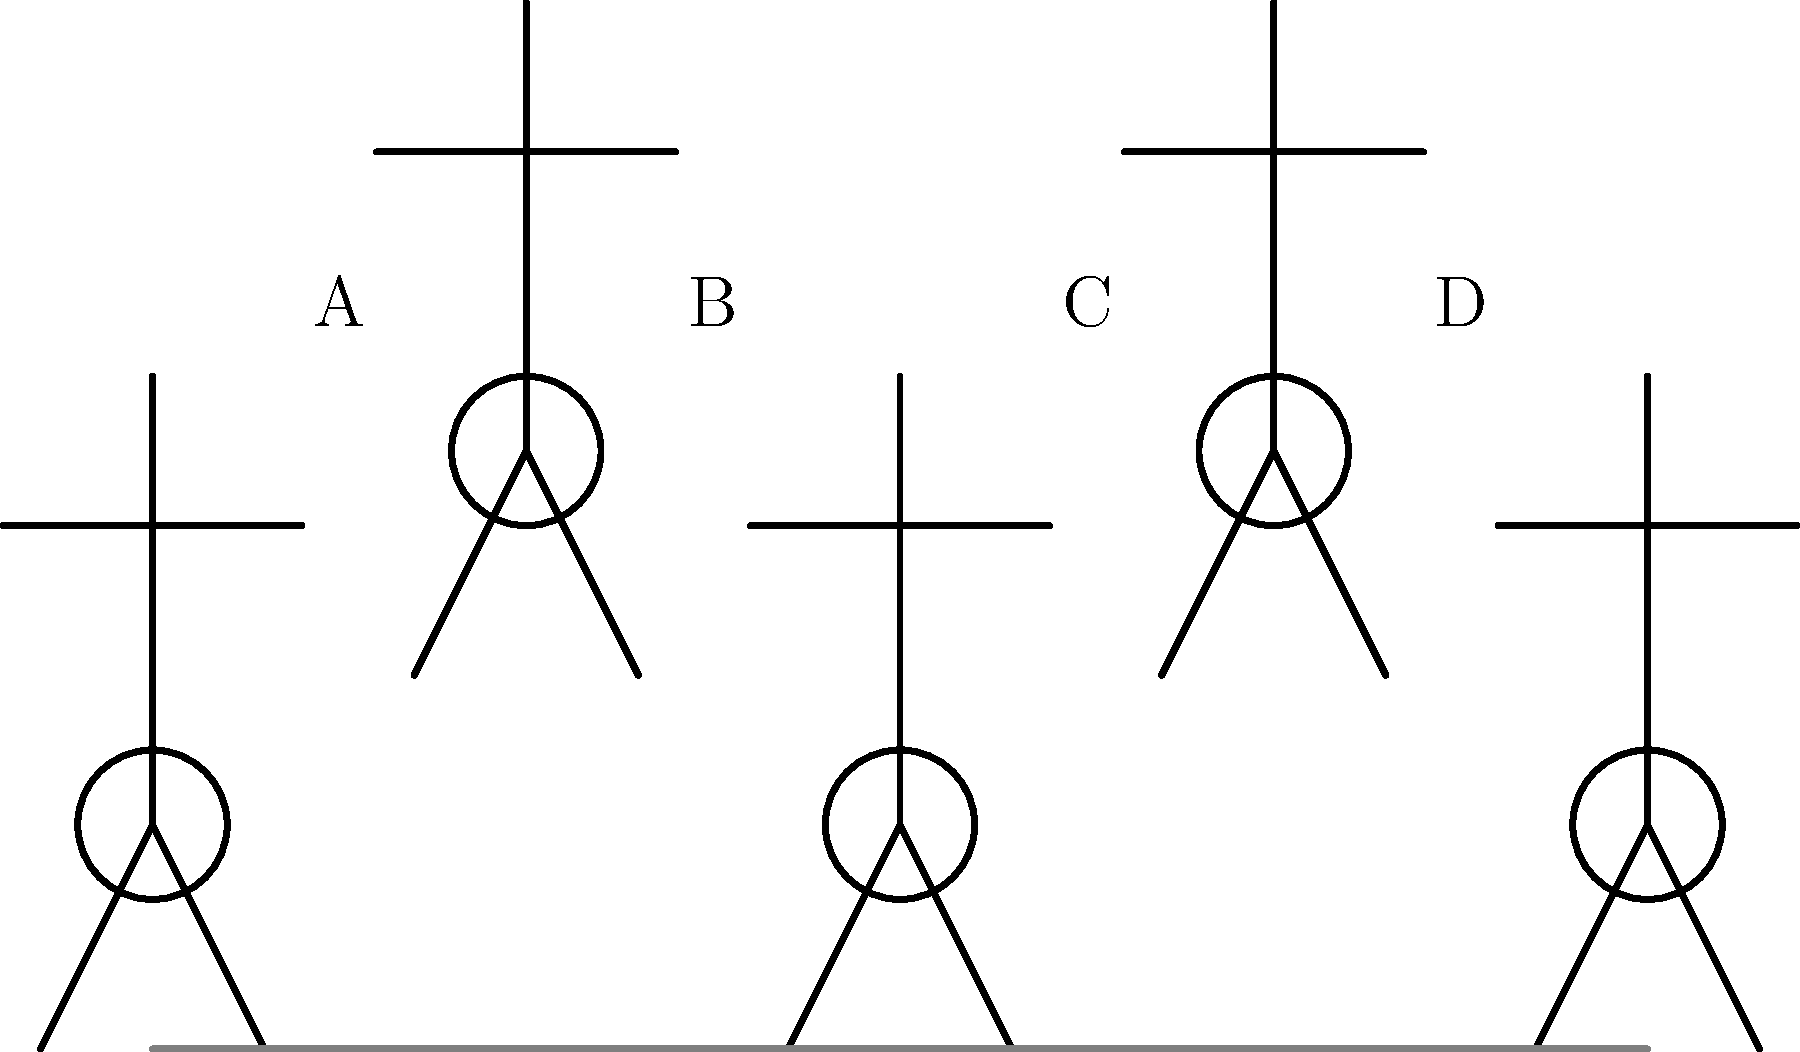As a program officer evaluating a biomechanics research proposal, you come across a diagram illustrating the running gait cycle. Which phase in the diagram represents the "flight phase" where neither foot is in contact with the ground, and why is this phase crucial for understanding the efficiency of a runner's biomechanics? To answer this question, let's analyze the running gait cycle depicted in the stick figure illustrations:

1. The running gait cycle is typically divided into two main phases: stance phase and swing phase.

2. In the diagram, we can see five stick figures representing different stages of the running cycle:

   A: Initial contact or heel strike
   B: Mid-stance
   C: Toe-off
   D: Mid-swing

3. The "flight phase" occurs when neither foot is in contact with the ground. This happens between toe-off (C) and the subsequent heel strike (A of the next cycle).

4. In the diagram, the flight phase is represented by the transition from position C to position D.

5. The flight phase is crucial for understanding running efficiency because:

   a) It demonstrates the runner's ability to generate vertical force and overcome gravity.
   b) The duration and height of the flight phase can indicate the runner's power output.
   c) It provides insights into the runner's energy conservation and transfer between kinetic and potential energy.
   d) The length of the flight phase affects stride length and frequency, which are key factors in running speed and efficiency.

6. From a biomechanics research perspective, studying the flight phase can help in:

   a) Optimizing running technique
   b) Designing better running shoes
   c) Preventing injuries by understanding impact forces
   d) Improving athletic performance

Understanding the flight phase is essential for evaluating the potential impact and relevance of biomechanics research proposals related to running efficiency and performance.
Answer: Phase C to D; crucial for assessing power output, energy transfer, and overall running efficiency. 